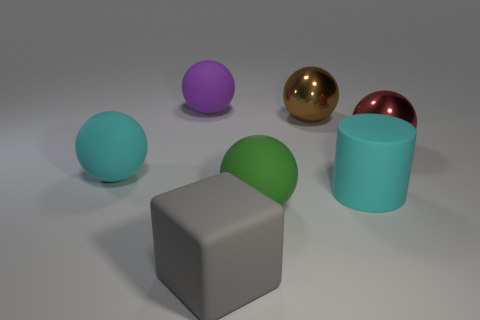Is there a gray cube made of the same material as the large purple ball?
Ensure brevity in your answer.  Yes. Is the number of big cyan matte balls that are behind the big brown ball less than the number of tiny green rubber cubes?
Offer a very short reply. No. What is the big cyan object that is to the left of the large sphere that is in front of the big cyan cylinder made of?
Ensure brevity in your answer.  Rubber. There is a big rubber thing that is both to the right of the purple matte ball and on the left side of the large green matte sphere; what is its shape?
Offer a very short reply. Cube. What number of other objects are there of the same color as the cube?
Make the answer very short. 0. What number of objects are spheres behind the brown ball or tiny blue metallic things?
Your answer should be compact. 1. Is the color of the matte cube the same as the big metal ball that is behind the red metallic object?
Make the answer very short. No. Are there any other things that are the same size as the red object?
Your answer should be very brief. Yes. What size is the cyan matte thing that is left of the rubber sphere that is on the right side of the large rubber cube?
Provide a succinct answer. Large. What number of things are either large gray rubber cubes or matte objects that are in front of the brown ball?
Ensure brevity in your answer.  4. 